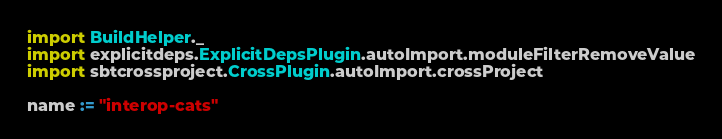<code> <loc_0><loc_0><loc_500><loc_500><_Scala_>import BuildHelper._
import explicitdeps.ExplicitDepsPlugin.autoImport.moduleFilterRemoveValue
import sbtcrossproject.CrossPlugin.autoImport.crossProject

name := "interop-cats"
</code> 